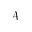Convert formula to latex. <formula><loc_0><loc_0><loc_500><loc_500>\mathcal { A }</formula> 